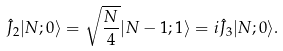Convert formula to latex. <formula><loc_0><loc_0><loc_500><loc_500>\hat { J } _ { 2 } | N ; 0 \rangle = \sqrt { \frac { N } { 4 } } | N - 1 ; 1 \rangle = i \hat { J } _ { 3 } | N ; 0 \rangle .</formula> 